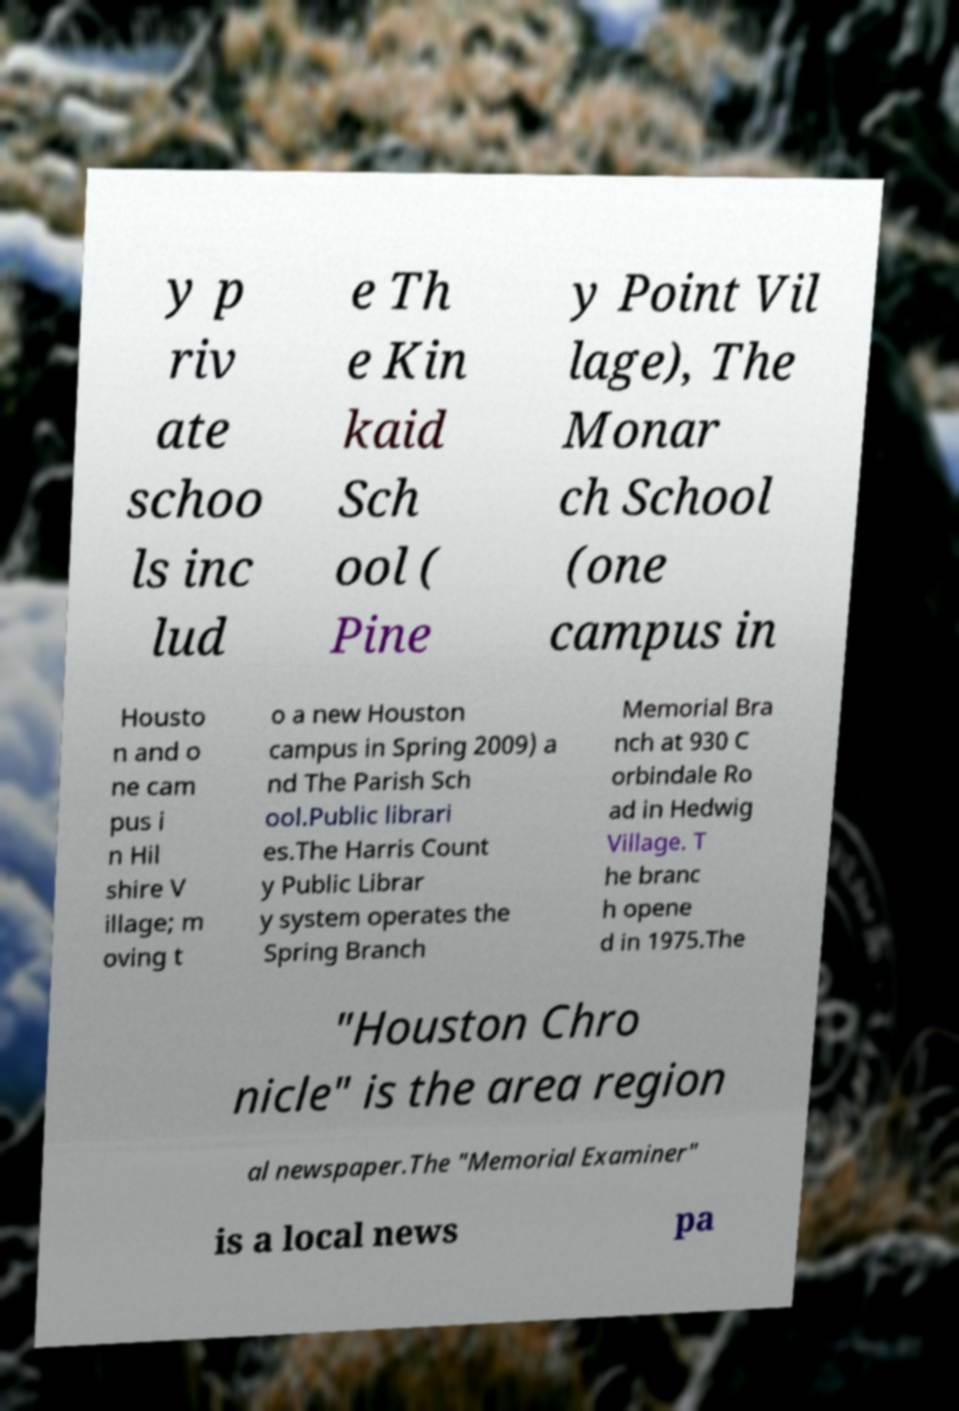Could you assist in decoding the text presented in this image and type it out clearly? y p riv ate schoo ls inc lud e Th e Kin kaid Sch ool ( Pine y Point Vil lage), The Monar ch School (one campus in Housto n and o ne cam pus i n Hil shire V illage; m oving t o a new Houston campus in Spring 2009) a nd The Parish Sch ool.Public librari es.The Harris Count y Public Librar y system operates the Spring Branch Memorial Bra nch at 930 C orbindale Ro ad in Hedwig Village. T he branc h opene d in 1975.The "Houston Chro nicle" is the area region al newspaper.The "Memorial Examiner" is a local news pa 